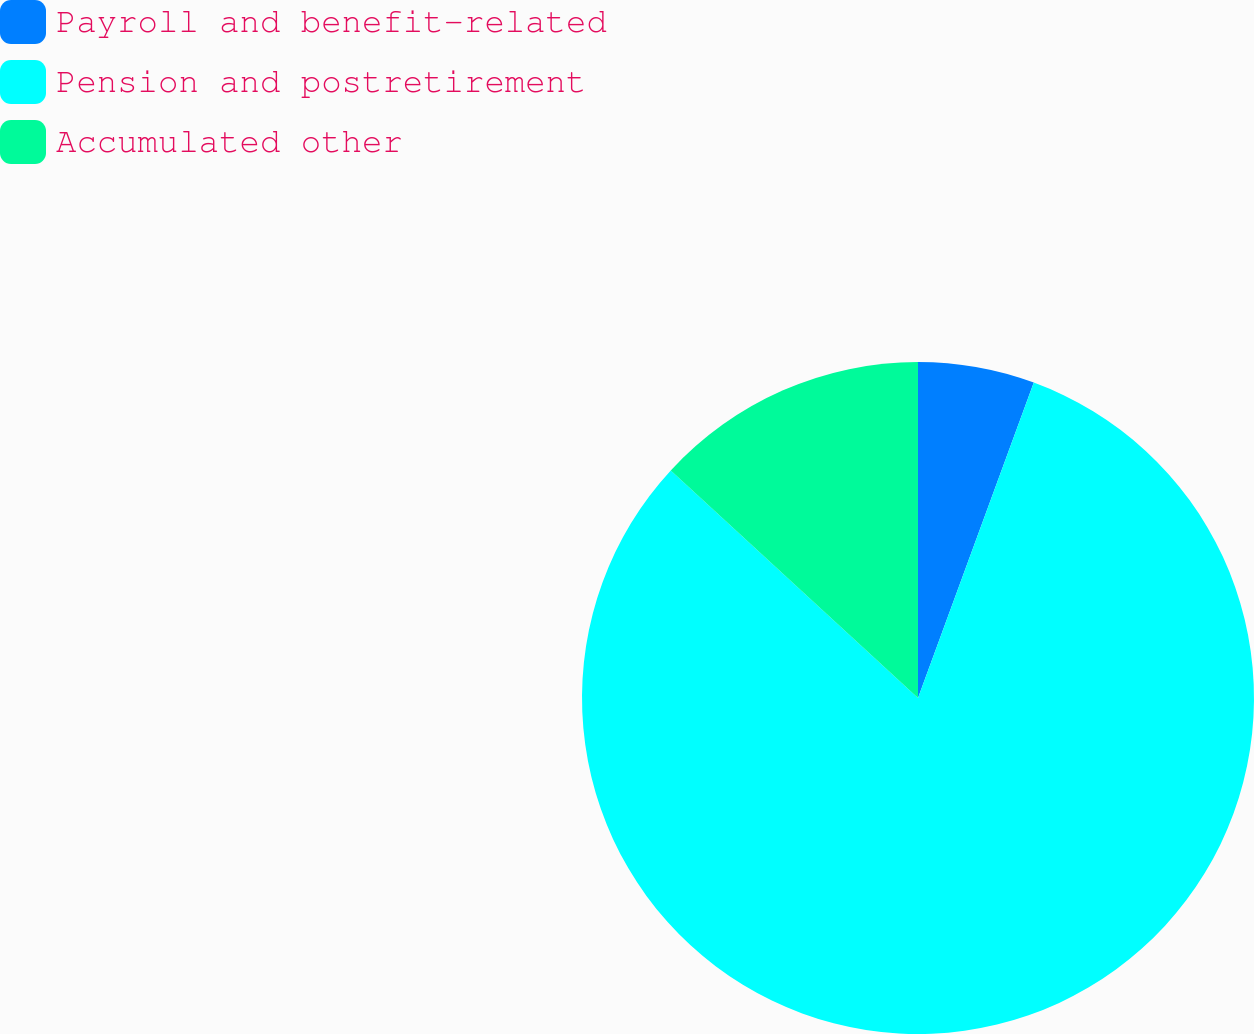Convert chart. <chart><loc_0><loc_0><loc_500><loc_500><pie_chart><fcel>Payroll and benefit-related<fcel>Pension and postretirement<fcel>Accumulated other<nl><fcel>5.6%<fcel>81.24%<fcel>13.16%<nl></chart> 